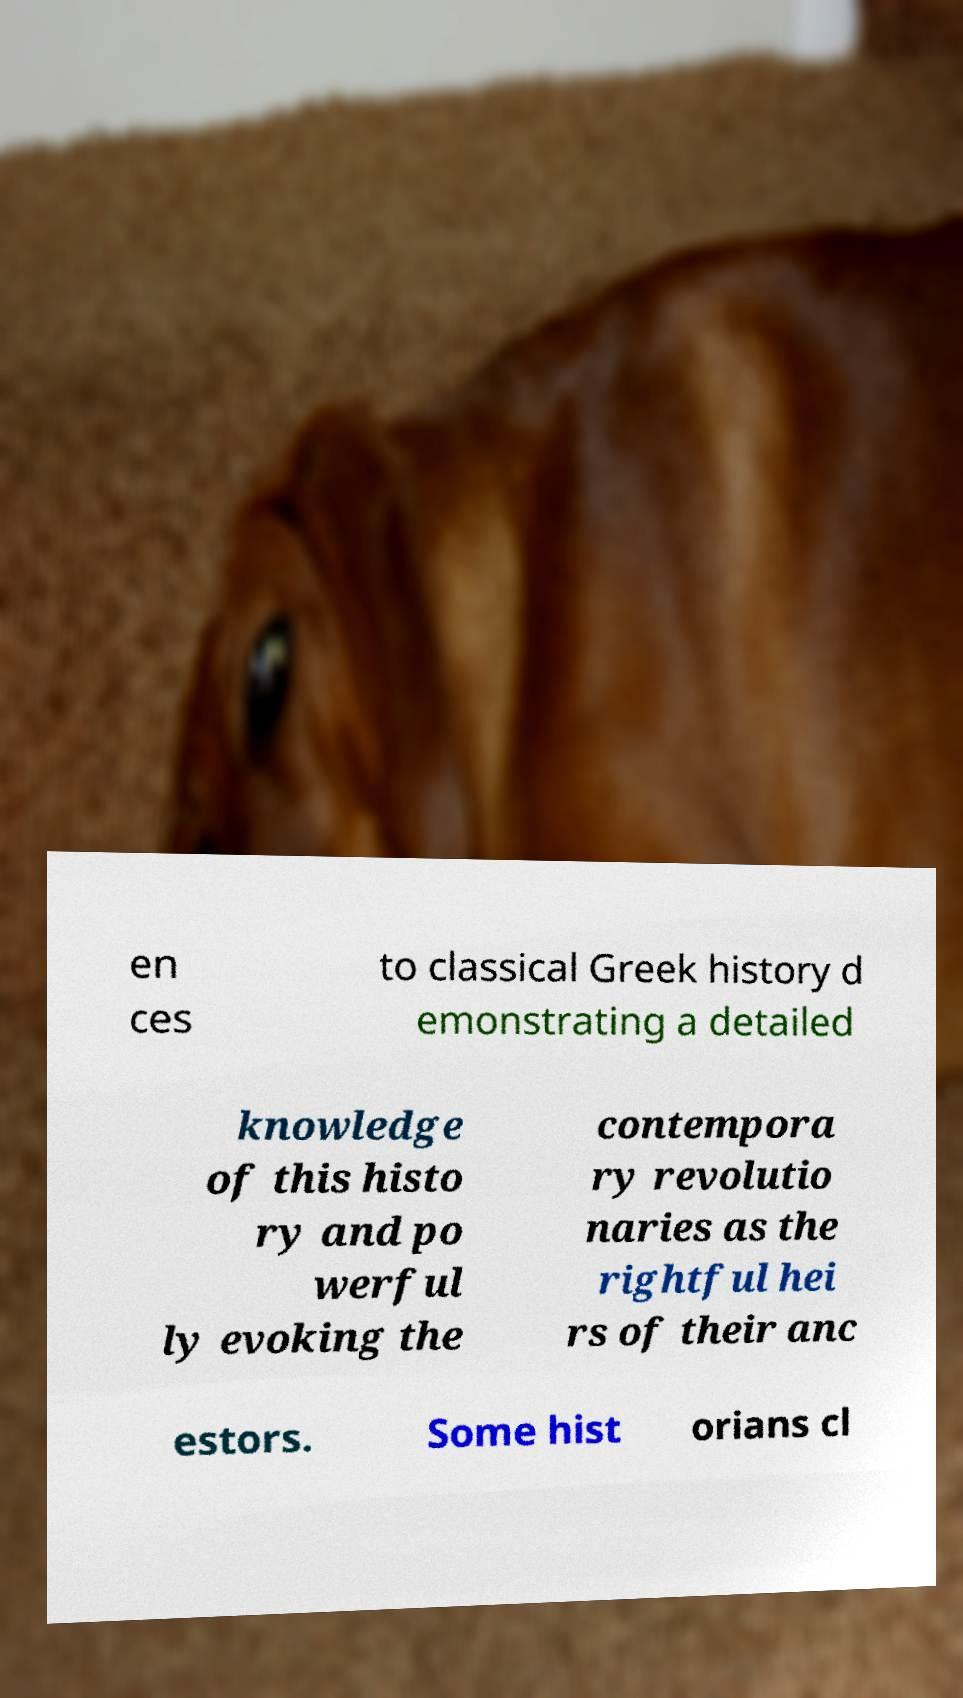Please read and relay the text visible in this image. What does it say? en ces to classical Greek history d emonstrating a detailed knowledge of this histo ry and po werful ly evoking the contempora ry revolutio naries as the rightful hei rs of their anc estors. Some hist orians cl 